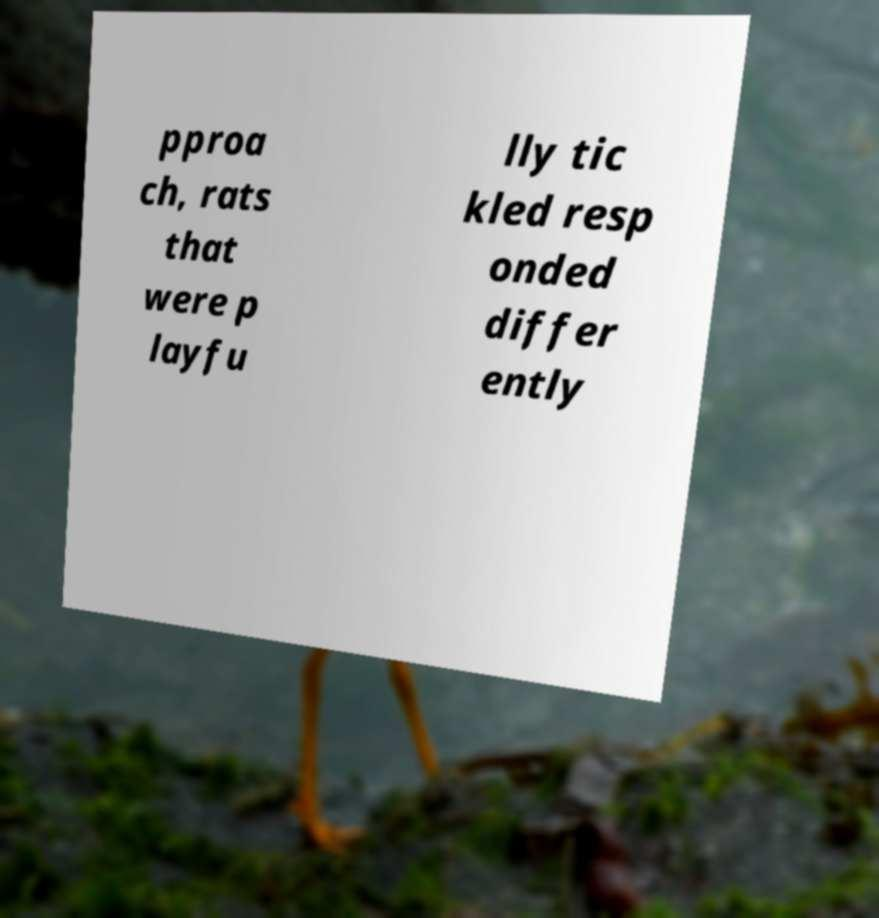Please identify and transcribe the text found in this image. pproa ch, rats that were p layfu lly tic kled resp onded differ ently 